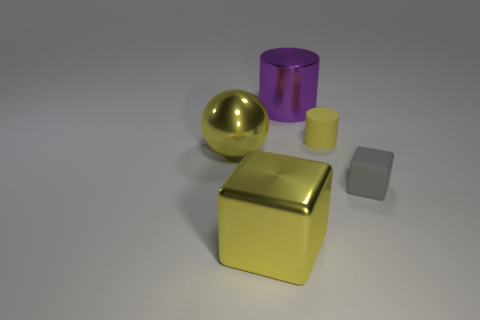Add 2 gray things. How many objects exist? 7 Subtract all yellow cylinders. How many cylinders are left? 1 Subtract 1 balls. How many balls are left? 0 Subtract all yellow cubes. Subtract all yellow balls. How many cubes are left? 1 Subtract all cyan blocks. How many purple cylinders are left? 1 Subtract all big yellow balls. Subtract all small matte blocks. How many objects are left? 3 Add 2 gray rubber things. How many gray rubber things are left? 3 Add 2 small purple objects. How many small purple objects exist? 2 Subtract 0 green cubes. How many objects are left? 5 Subtract all cylinders. How many objects are left? 3 